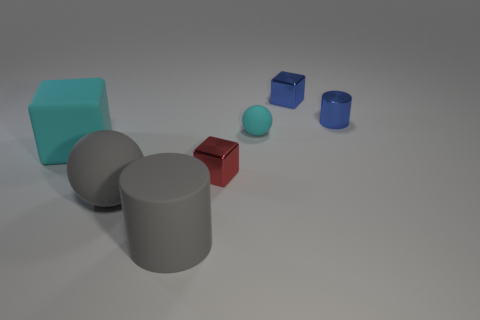Subtract all tiny metal cubes. How many cubes are left? 1 Subtract all blue cubes. How many cubes are left? 2 Subtract 1 cylinders. How many cylinders are left? 1 Add 2 large cyan matte things. How many objects exist? 9 Add 5 large matte things. How many large matte things are left? 8 Add 2 matte balls. How many matte balls exist? 4 Subtract 1 red cubes. How many objects are left? 6 Subtract all cylinders. How many objects are left? 5 Subtract all cyan spheres. Subtract all yellow blocks. How many spheres are left? 1 Subtract all red cubes. How many blue spheres are left? 0 